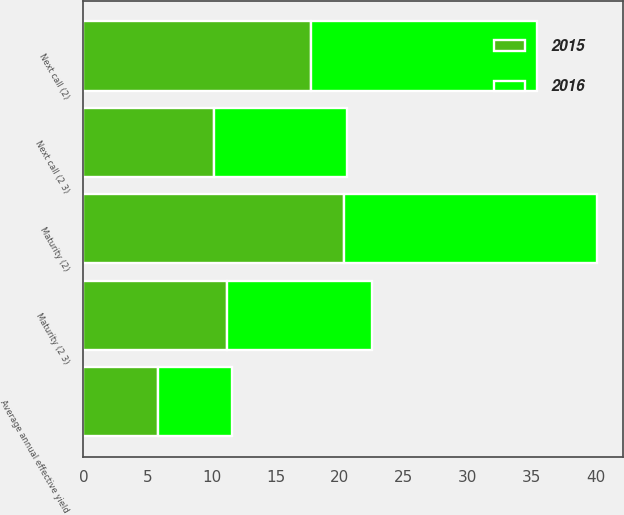<chart> <loc_0><loc_0><loc_500><loc_500><stacked_bar_chart><ecel><fcel>Average annual effective yield<fcel>Next call (2)<fcel>Maturity (2)<fcel>Next call (2 3)<fcel>Maturity (2 3)<nl><fcel>2016<fcel>5.74<fcel>17.6<fcel>19.8<fcel>10.4<fcel>11.3<nl><fcel>2015<fcel>5.83<fcel>17.8<fcel>20.3<fcel>10.2<fcel>11.2<nl></chart> 